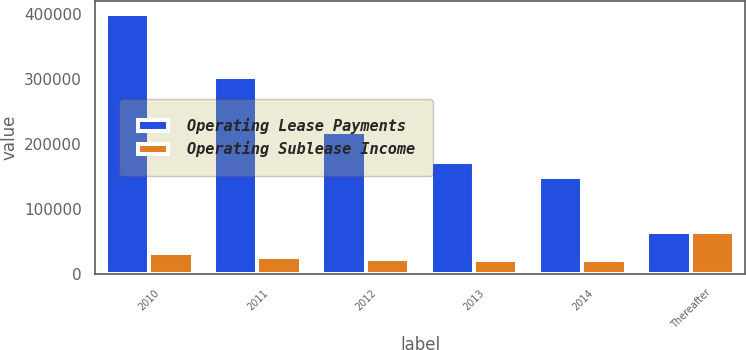Convert chart to OTSL. <chart><loc_0><loc_0><loc_500><loc_500><stacked_bar_chart><ecel><fcel>2010<fcel>2011<fcel>2012<fcel>2013<fcel>2014<fcel>Thereafter<nl><fcel>Operating Lease Payments<fcel>400095<fcel>303316<fcel>218112<fcel>172862<fcel>149389<fcel>64975<nl><fcel>Operating Sublease Income<fcel>33062<fcel>27051<fcel>23164<fcel>21982<fcel>21562<fcel>64975<nl></chart> 